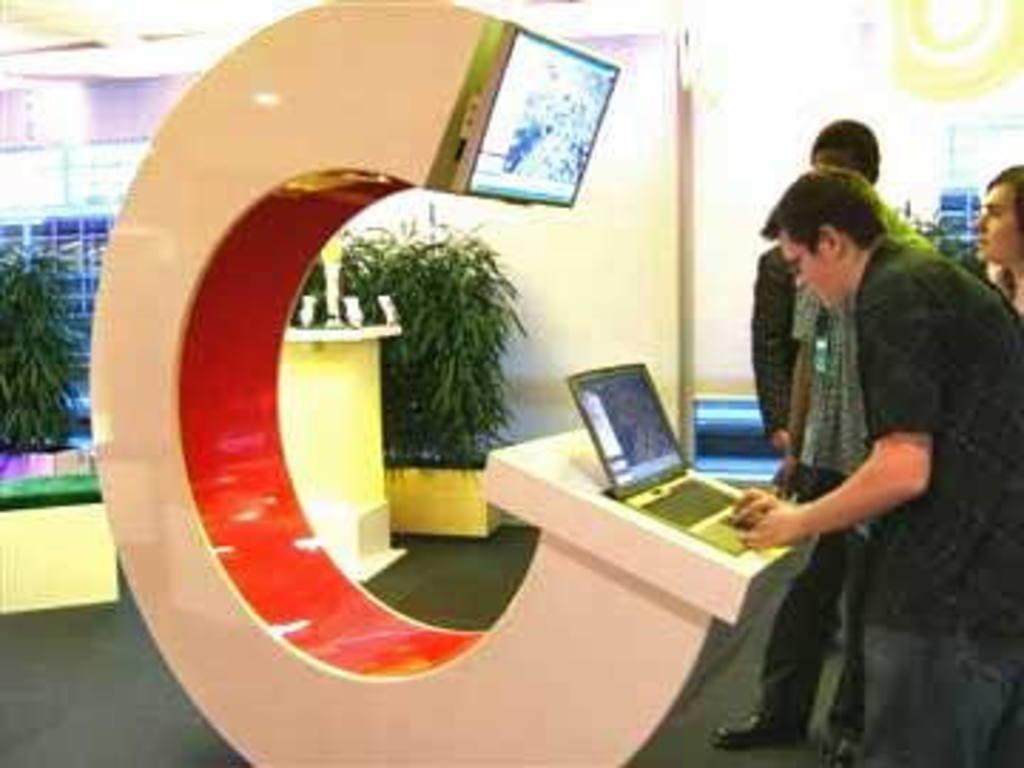Can you describe this image briefly? In the center of the image we can see three persons are standing. And the front person is working on the laptop. In front of them, we can see one c shape architecture. On the architecture, we can see one laptop and monitor. In the background there is a wall, plants and a few other objects. 